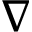<formula> <loc_0><loc_0><loc_500><loc_500>\nabla</formula> 